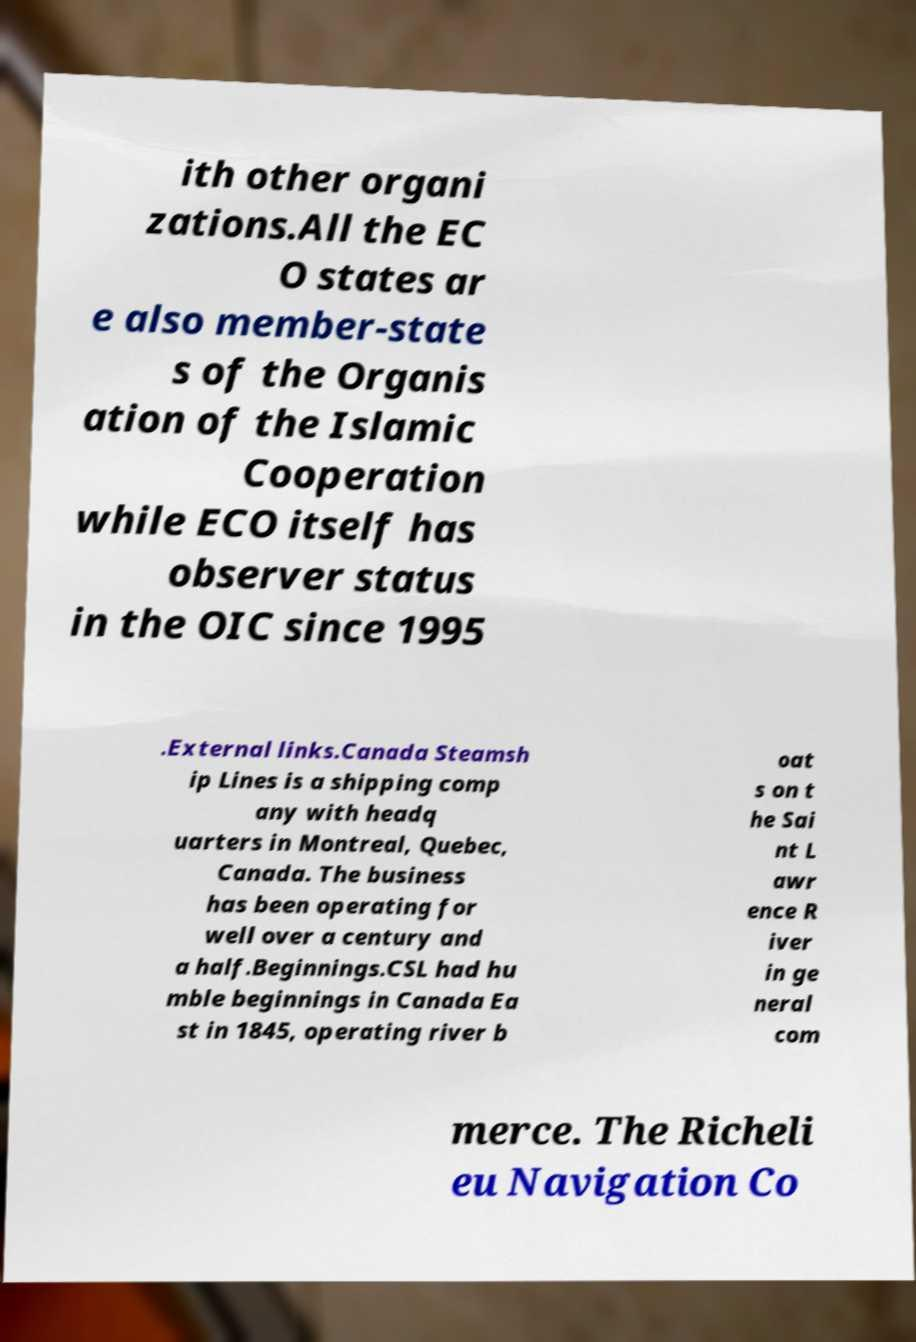Please read and relay the text visible in this image. What does it say? ith other organi zations.All the EC O states ar e also member-state s of the Organis ation of the Islamic Cooperation while ECO itself has observer status in the OIC since 1995 .External links.Canada Steamsh ip Lines is a shipping comp any with headq uarters in Montreal, Quebec, Canada. The business has been operating for well over a century and a half.Beginnings.CSL had hu mble beginnings in Canada Ea st in 1845, operating river b oat s on t he Sai nt L awr ence R iver in ge neral com merce. The Richeli eu Navigation Co 